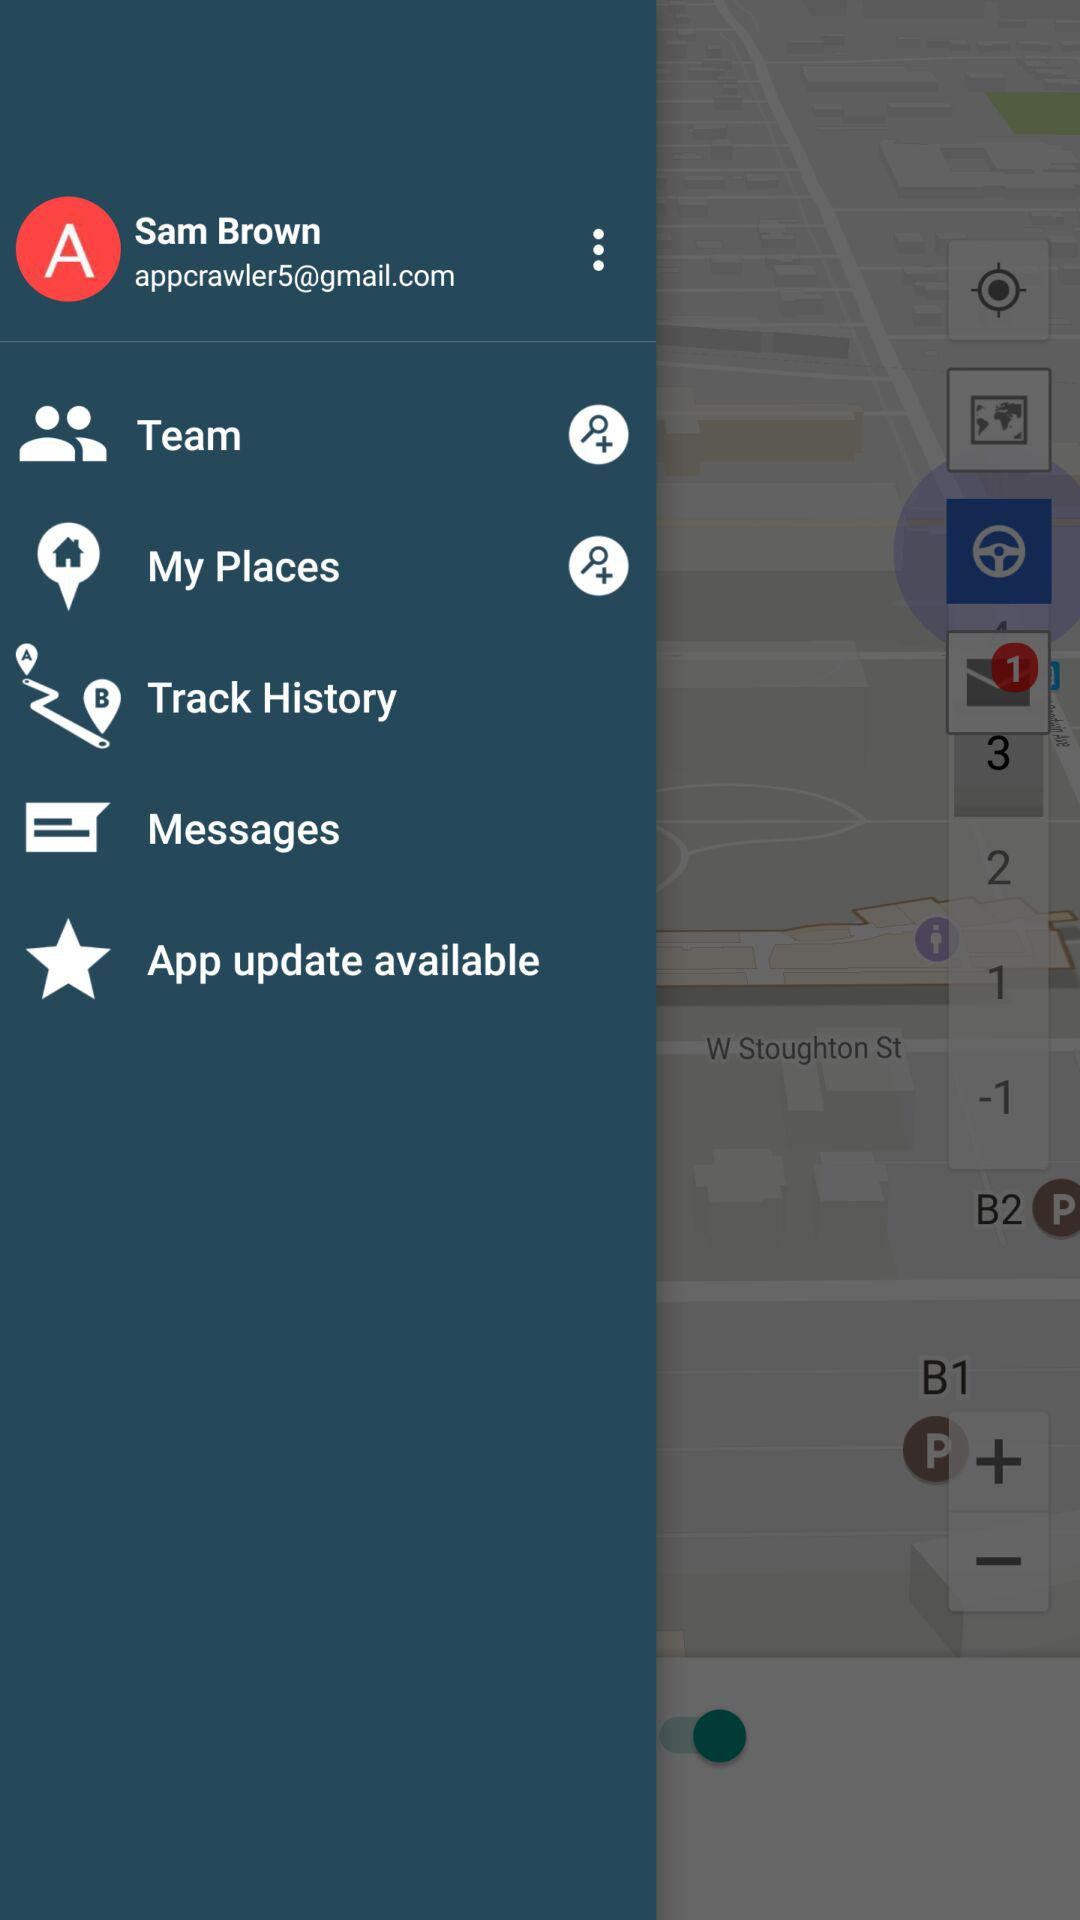What is the name of the user? The name of the user is Sam Brown. 